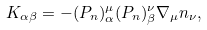Convert formula to latex. <formula><loc_0><loc_0><loc_500><loc_500>K _ { \alpha \beta } = - ( P _ { n } ) ^ { \mu } _ { \alpha } ( P _ { n } ) ^ { \nu } _ { \beta } \nabla _ { \mu } n _ { \nu } ,</formula> 